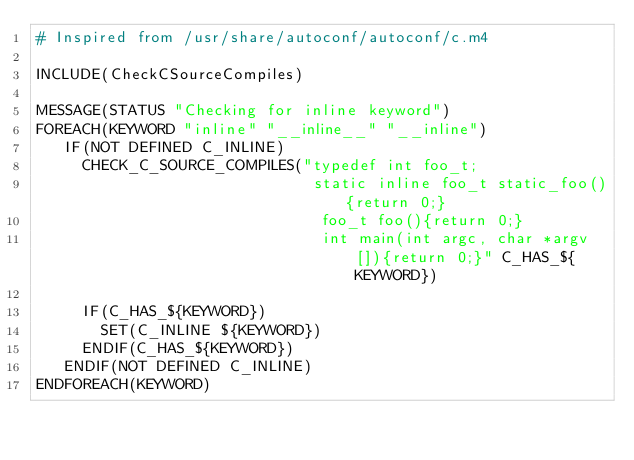Convert code to text. <code><loc_0><loc_0><loc_500><loc_500><_CMake_># Inspired from /usr/share/autoconf/autoconf/c.m4

INCLUDE(CheckCSourceCompiles)

MESSAGE(STATUS "Checking for inline keyword")
FOREACH(KEYWORD "inline" "__inline__" "__inline")
   IF(NOT DEFINED C_INLINE)
     CHECK_C_SOURCE_COMPILES("typedef int foo_t;
                              static inline foo_t static_foo(){return 0;}
                               foo_t foo(){return 0;}
                               int main(int argc, char *argv[]){return 0;}" C_HAS_${KEYWORD})

     IF(C_HAS_${KEYWORD})
       SET(C_INLINE ${KEYWORD})
     ENDIF(C_HAS_${KEYWORD})
   ENDIF(NOT DEFINED C_INLINE)
ENDFOREACH(KEYWORD)
</code> 